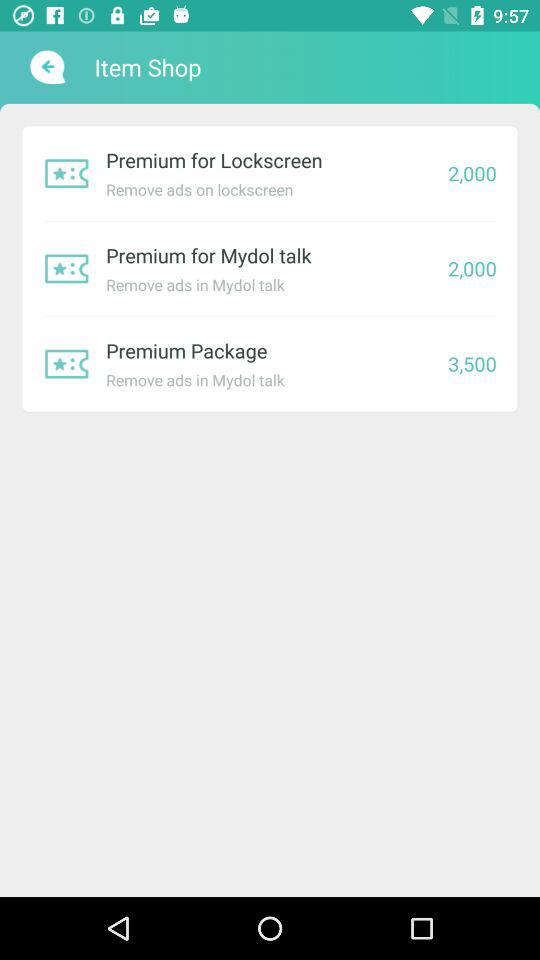What is the price of "Premium Package"? The price is 3,500. 